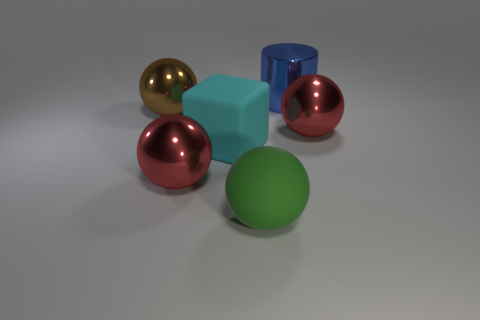How many objects are either large red things that are left of the big blue shiny thing or large metal spheres to the right of the large brown sphere?
Offer a terse response. 2. How many other objects are there of the same color as the large cylinder?
Your response must be concise. 0. Do the cyan thing and the shiny thing in front of the large matte block have the same shape?
Your answer should be very brief. No. Are there fewer big green rubber things behind the cylinder than big objects that are in front of the big cyan object?
Your answer should be compact. Yes. There is a big brown thing that is the same shape as the green rubber object; what material is it?
Offer a terse response. Metal. Is there any other thing that is the same material as the big green thing?
Offer a very short reply. Yes. Is the cylinder the same color as the rubber block?
Offer a terse response. No. What is the shape of the blue thing that is the same material as the brown object?
Offer a terse response. Cylinder. How many red objects have the same shape as the blue thing?
Your response must be concise. 0. The red object that is in front of the big red object right of the large green thing is what shape?
Ensure brevity in your answer.  Sphere. 